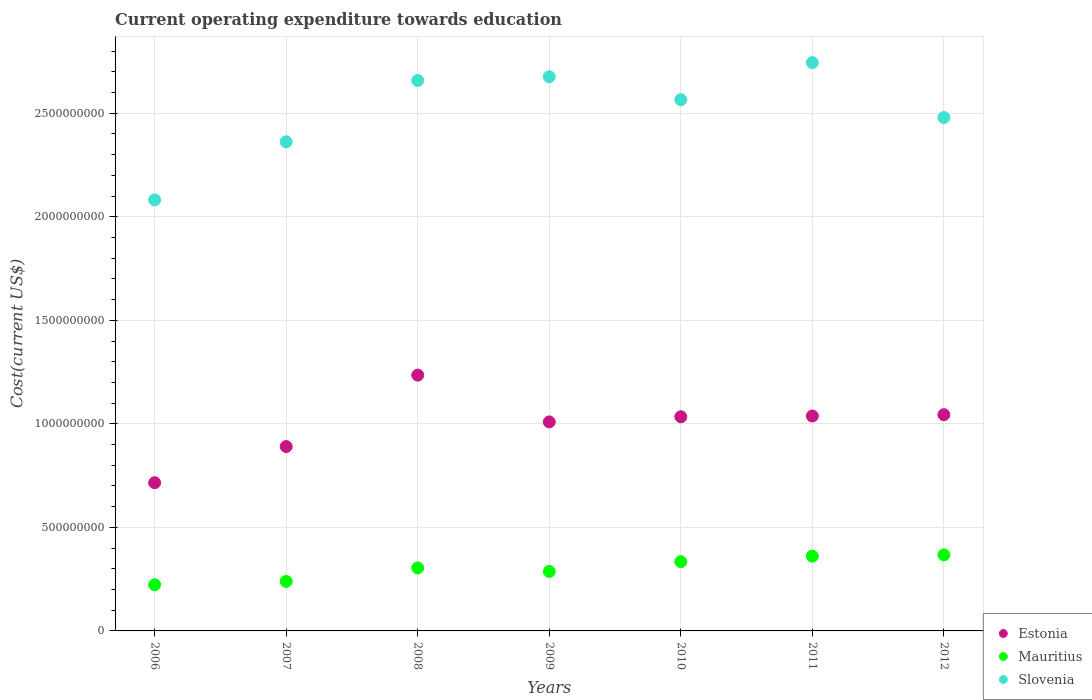What is the expenditure towards education in Estonia in 2006?
Offer a terse response. 7.16e+08. Across all years, what is the maximum expenditure towards education in Estonia?
Keep it short and to the point. 1.24e+09. Across all years, what is the minimum expenditure towards education in Mauritius?
Your answer should be very brief. 2.23e+08. In which year was the expenditure towards education in Estonia maximum?
Your answer should be very brief. 2008. What is the total expenditure towards education in Estonia in the graph?
Offer a very short reply. 6.97e+09. What is the difference between the expenditure towards education in Estonia in 2008 and that in 2010?
Offer a very short reply. 2.01e+08. What is the difference between the expenditure towards education in Estonia in 2012 and the expenditure towards education in Slovenia in 2007?
Give a very brief answer. -1.32e+09. What is the average expenditure towards education in Slovenia per year?
Provide a succinct answer. 2.51e+09. In the year 2008, what is the difference between the expenditure towards education in Slovenia and expenditure towards education in Mauritius?
Give a very brief answer. 2.35e+09. In how many years, is the expenditure towards education in Slovenia greater than 2600000000 US$?
Offer a very short reply. 3. What is the ratio of the expenditure towards education in Mauritius in 2006 to that in 2010?
Provide a short and direct response. 0.67. Is the expenditure towards education in Slovenia in 2006 less than that in 2008?
Offer a very short reply. Yes. What is the difference between the highest and the second highest expenditure towards education in Mauritius?
Offer a very short reply. 6.33e+06. What is the difference between the highest and the lowest expenditure towards education in Estonia?
Ensure brevity in your answer.  5.20e+08. Is the sum of the expenditure towards education in Slovenia in 2007 and 2012 greater than the maximum expenditure towards education in Mauritius across all years?
Your answer should be very brief. Yes. Is it the case that in every year, the sum of the expenditure towards education in Estonia and expenditure towards education in Slovenia  is greater than the expenditure towards education in Mauritius?
Provide a short and direct response. Yes. Does the expenditure towards education in Estonia monotonically increase over the years?
Provide a succinct answer. No. Is the expenditure towards education in Mauritius strictly less than the expenditure towards education in Slovenia over the years?
Offer a very short reply. Yes. How many dotlines are there?
Offer a very short reply. 3. How many years are there in the graph?
Your response must be concise. 7. Are the values on the major ticks of Y-axis written in scientific E-notation?
Offer a terse response. No. Does the graph contain any zero values?
Keep it short and to the point. No. Where does the legend appear in the graph?
Your answer should be compact. Bottom right. How many legend labels are there?
Your response must be concise. 3. What is the title of the graph?
Provide a succinct answer. Current operating expenditure towards education. Does "Guinea" appear as one of the legend labels in the graph?
Provide a succinct answer. No. What is the label or title of the Y-axis?
Ensure brevity in your answer.  Cost(current US$). What is the Cost(current US$) in Estonia in 2006?
Provide a short and direct response. 7.16e+08. What is the Cost(current US$) in Mauritius in 2006?
Your response must be concise. 2.23e+08. What is the Cost(current US$) of Slovenia in 2006?
Your response must be concise. 2.08e+09. What is the Cost(current US$) in Estonia in 2007?
Your response must be concise. 8.90e+08. What is the Cost(current US$) in Mauritius in 2007?
Provide a succinct answer. 2.39e+08. What is the Cost(current US$) in Slovenia in 2007?
Ensure brevity in your answer.  2.36e+09. What is the Cost(current US$) in Estonia in 2008?
Make the answer very short. 1.24e+09. What is the Cost(current US$) of Mauritius in 2008?
Give a very brief answer. 3.04e+08. What is the Cost(current US$) of Slovenia in 2008?
Your response must be concise. 2.66e+09. What is the Cost(current US$) in Estonia in 2009?
Provide a short and direct response. 1.01e+09. What is the Cost(current US$) of Mauritius in 2009?
Keep it short and to the point. 2.87e+08. What is the Cost(current US$) of Slovenia in 2009?
Give a very brief answer. 2.68e+09. What is the Cost(current US$) of Estonia in 2010?
Your answer should be very brief. 1.03e+09. What is the Cost(current US$) in Mauritius in 2010?
Offer a very short reply. 3.34e+08. What is the Cost(current US$) in Slovenia in 2010?
Your answer should be very brief. 2.57e+09. What is the Cost(current US$) in Estonia in 2011?
Keep it short and to the point. 1.04e+09. What is the Cost(current US$) in Mauritius in 2011?
Ensure brevity in your answer.  3.61e+08. What is the Cost(current US$) of Slovenia in 2011?
Offer a terse response. 2.74e+09. What is the Cost(current US$) in Estonia in 2012?
Your answer should be compact. 1.04e+09. What is the Cost(current US$) of Mauritius in 2012?
Offer a very short reply. 3.67e+08. What is the Cost(current US$) in Slovenia in 2012?
Make the answer very short. 2.48e+09. Across all years, what is the maximum Cost(current US$) in Estonia?
Keep it short and to the point. 1.24e+09. Across all years, what is the maximum Cost(current US$) in Mauritius?
Keep it short and to the point. 3.67e+08. Across all years, what is the maximum Cost(current US$) in Slovenia?
Ensure brevity in your answer.  2.74e+09. Across all years, what is the minimum Cost(current US$) in Estonia?
Ensure brevity in your answer.  7.16e+08. Across all years, what is the minimum Cost(current US$) of Mauritius?
Make the answer very short. 2.23e+08. Across all years, what is the minimum Cost(current US$) in Slovenia?
Make the answer very short. 2.08e+09. What is the total Cost(current US$) of Estonia in the graph?
Keep it short and to the point. 6.97e+09. What is the total Cost(current US$) of Mauritius in the graph?
Provide a short and direct response. 2.12e+09. What is the total Cost(current US$) in Slovenia in the graph?
Provide a succinct answer. 1.76e+1. What is the difference between the Cost(current US$) of Estonia in 2006 and that in 2007?
Provide a succinct answer. -1.75e+08. What is the difference between the Cost(current US$) of Mauritius in 2006 and that in 2007?
Keep it short and to the point. -1.62e+07. What is the difference between the Cost(current US$) of Slovenia in 2006 and that in 2007?
Make the answer very short. -2.80e+08. What is the difference between the Cost(current US$) in Estonia in 2006 and that in 2008?
Your answer should be compact. -5.20e+08. What is the difference between the Cost(current US$) of Mauritius in 2006 and that in 2008?
Give a very brief answer. -8.14e+07. What is the difference between the Cost(current US$) of Slovenia in 2006 and that in 2008?
Give a very brief answer. -5.76e+08. What is the difference between the Cost(current US$) of Estonia in 2006 and that in 2009?
Give a very brief answer. -2.94e+08. What is the difference between the Cost(current US$) of Mauritius in 2006 and that in 2009?
Make the answer very short. -6.43e+07. What is the difference between the Cost(current US$) in Slovenia in 2006 and that in 2009?
Offer a very short reply. -5.94e+08. What is the difference between the Cost(current US$) of Estonia in 2006 and that in 2010?
Ensure brevity in your answer.  -3.19e+08. What is the difference between the Cost(current US$) of Mauritius in 2006 and that in 2010?
Make the answer very short. -1.11e+08. What is the difference between the Cost(current US$) in Slovenia in 2006 and that in 2010?
Ensure brevity in your answer.  -4.84e+08. What is the difference between the Cost(current US$) in Estonia in 2006 and that in 2011?
Your answer should be very brief. -3.22e+08. What is the difference between the Cost(current US$) of Mauritius in 2006 and that in 2011?
Keep it short and to the point. -1.38e+08. What is the difference between the Cost(current US$) in Slovenia in 2006 and that in 2011?
Make the answer very short. -6.62e+08. What is the difference between the Cost(current US$) in Estonia in 2006 and that in 2012?
Make the answer very short. -3.29e+08. What is the difference between the Cost(current US$) of Mauritius in 2006 and that in 2012?
Provide a succinct answer. -1.44e+08. What is the difference between the Cost(current US$) in Slovenia in 2006 and that in 2012?
Provide a succinct answer. -3.98e+08. What is the difference between the Cost(current US$) in Estonia in 2007 and that in 2008?
Offer a terse response. -3.45e+08. What is the difference between the Cost(current US$) in Mauritius in 2007 and that in 2008?
Your response must be concise. -6.53e+07. What is the difference between the Cost(current US$) of Slovenia in 2007 and that in 2008?
Keep it short and to the point. -2.96e+08. What is the difference between the Cost(current US$) in Estonia in 2007 and that in 2009?
Make the answer very short. -1.19e+08. What is the difference between the Cost(current US$) in Mauritius in 2007 and that in 2009?
Your answer should be very brief. -4.81e+07. What is the difference between the Cost(current US$) in Slovenia in 2007 and that in 2009?
Give a very brief answer. -3.14e+08. What is the difference between the Cost(current US$) in Estonia in 2007 and that in 2010?
Your response must be concise. -1.44e+08. What is the difference between the Cost(current US$) in Mauritius in 2007 and that in 2010?
Your response must be concise. -9.53e+07. What is the difference between the Cost(current US$) of Slovenia in 2007 and that in 2010?
Your response must be concise. -2.03e+08. What is the difference between the Cost(current US$) in Estonia in 2007 and that in 2011?
Your answer should be very brief. -1.48e+08. What is the difference between the Cost(current US$) in Mauritius in 2007 and that in 2011?
Provide a short and direct response. -1.22e+08. What is the difference between the Cost(current US$) of Slovenia in 2007 and that in 2011?
Provide a succinct answer. -3.82e+08. What is the difference between the Cost(current US$) of Estonia in 2007 and that in 2012?
Ensure brevity in your answer.  -1.54e+08. What is the difference between the Cost(current US$) of Mauritius in 2007 and that in 2012?
Your response must be concise. -1.28e+08. What is the difference between the Cost(current US$) in Slovenia in 2007 and that in 2012?
Give a very brief answer. -1.17e+08. What is the difference between the Cost(current US$) in Estonia in 2008 and that in 2009?
Offer a very short reply. 2.26e+08. What is the difference between the Cost(current US$) of Mauritius in 2008 and that in 2009?
Make the answer very short. 1.71e+07. What is the difference between the Cost(current US$) of Slovenia in 2008 and that in 2009?
Give a very brief answer. -1.81e+07. What is the difference between the Cost(current US$) of Estonia in 2008 and that in 2010?
Make the answer very short. 2.01e+08. What is the difference between the Cost(current US$) of Mauritius in 2008 and that in 2010?
Your response must be concise. -3.00e+07. What is the difference between the Cost(current US$) in Slovenia in 2008 and that in 2010?
Keep it short and to the point. 9.27e+07. What is the difference between the Cost(current US$) in Estonia in 2008 and that in 2011?
Your response must be concise. 1.97e+08. What is the difference between the Cost(current US$) in Mauritius in 2008 and that in 2011?
Your response must be concise. -5.66e+07. What is the difference between the Cost(current US$) in Slovenia in 2008 and that in 2011?
Your answer should be very brief. -8.61e+07. What is the difference between the Cost(current US$) in Estonia in 2008 and that in 2012?
Give a very brief answer. 1.91e+08. What is the difference between the Cost(current US$) in Mauritius in 2008 and that in 2012?
Offer a very short reply. -6.30e+07. What is the difference between the Cost(current US$) of Slovenia in 2008 and that in 2012?
Give a very brief answer. 1.79e+08. What is the difference between the Cost(current US$) of Estonia in 2009 and that in 2010?
Offer a very short reply. -2.50e+07. What is the difference between the Cost(current US$) of Mauritius in 2009 and that in 2010?
Your answer should be compact. -4.72e+07. What is the difference between the Cost(current US$) of Slovenia in 2009 and that in 2010?
Make the answer very short. 1.11e+08. What is the difference between the Cost(current US$) in Estonia in 2009 and that in 2011?
Your answer should be very brief. -2.87e+07. What is the difference between the Cost(current US$) in Mauritius in 2009 and that in 2011?
Give a very brief answer. -7.38e+07. What is the difference between the Cost(current US$) in Slovenia in 2009 and that in 2011?
Offer a terse response. -6.79e+07. What is the difference between the Cost(current US$) of Estonia in 2009 and that in 2012?
Your response must be concise. -3.50e+07. What is the difference between the Cost(current US$) in Mauritius in 2009 and that in 2012?
Your response must be concise. -8.01e+07. What is the difference between the Cost(current US$) in Slovenia in 2009 and that in 2012?
Offer a terse response. 1.97e+08. What is the difference between the Cost(current US$) in Estonia in 2010 and that in 2011?
Your answer should be very brief. -3.72e+06. What is the difference between the Cost(current US$) of Mauritius in 2010 and that in 2011?
Keep it short and to the point. -2.66e+07. What is the difference between the Cost(current US$) in Slovenia in 2010 and that in 2011?
Make the answer very short. -1.79e+08. What is the difference between the Cost(current US$) of Estonia in 2010 and that in 2012?
Provide a succinct answer. -1.00e+07. What is the difference between the Cost(current US$) of Mauritius in 2010 and that in 2012?
Your answer should be very brief. -3.29e+07. What is the difference between the Cost(current US$) in Slovenia in 2010 and that in 2012?
Provide a succinct answer. 8.59e+07. What is the difference between the Cost(current US$) of Estonia in 2011 and that in 2012?
Your response must be concise. -6.29e+06. What is the difference between the Cost(current US$) of Mauritius in 2011 and that in 2012?
Your response must be concise. -6.33e+06. What is the difference between the Cost(current US$) in Slovenia in 2011 and that in 2012?
Your answer should be very brief. 2.65e+08. What is the difference between the Cost(current US$) of Estonia in 2006 and the Cost(current US$) of Mauritius in 2007?
Give a very brief answer. 4.77e+08. What is the difference between the Cost(current US$) in Estonia in 2006 and the Cost(current US$) in Slovenia in 2007?
Your response must be concise. -1.65e+09. What is the difference between the Cost(current US$) of Mauritius in 2006 and the Cost(current US$) of Slovenia in 2007?
Ensure brevity in your answer.  -2.14e+09. What is the difference between the Cost(current US$) of Estonia in 2006 and the Cost(current US$) of Mauritius in 2008?
Make the answer very short. 4.11e+08. What is the difference between the Cost(current US$) of Estonia in 2006 and the Cost(current US$) of Slovenia in 2008?
Ensure brevity in your answer.  -1.94e+09. What is the difference between the Cost(current US$) in Mauritius in 2006 and the Cost(current US$) in Slovenia in 2008?
Keep it short and to the point. -2.44e+09. What is the difference between the Cost(current US$) in Estonia in 2006 and the Cost(current US$) in Mauritius in 2009?
Provide a succinct answer. 4.28e+08. What is the difference between the Cost(current US$) of Estonia in 2006 and the Cost(current US$) of Slovenia in 2009?
Provide a succinct answer. -1.96e+09. What is the difference between the Cost(current US$) in Mauritius in 2006 and the Cost(current US$) in Slovenia in 2009?
Keep it short and to the point. -2.45e+09. What is the difference between the Cost(current US$) of Estonia in 2006 and the Cost(current US$) of Mauritius in 2010?
Keep it short and to the point. 3.81e+08. What is the difference between the Cost(current US$) of Estonia in 2006 and the Cost(current US$) of Slovenia in 2010?
Offer a very short reply. -1.85e+09. What is the difference between the Cost(current US$) of Mauritius in 2006 and the Cost(current US$) of Slovenia in 2010?
Offer a terse response. -2.34e+09. What is the difference between the Cost(current US$) in Estonia in 2006 and the Cost(current US$) in Mauritius in 2011?
Keep it short and to the point. 3.55e+08. What is the difference between the Cost(current US$) in Estonia in 2006 and the Cost(current US$) in Slovenia in 2011?
Keep it short and to the point. -2.03e+09. What is the difference between the Cost(current US$) of Mauritius in 2006 and the Cost(current US$) of Slovenia in 2011?
Your response must be concise. -2.52e+09. What is the difference between the Cost(current US$) of Estonia in 2006 and the Cost(current US$) of Mauritius in 2012?
Your response must be concise. 3.48e+08. What is the difference between the Cost(current US$) in Estonia in 2006 and the Cost(current US$) in Slovenia in 2012?
Provide a short and direct response. -1.76e+09. What is the difference between the Cost(current US$) in Mauritius in 2006 and the Cost(current US$) in Slovenia in 2012?
Make the answer very short. -2.26e+09. What is the difference between the Cost(current US$) in Estonia in 2007 and the Cost(current US$) in Mauritius in 2008?
Offer a very short reply. 5.86e+08. What is the difference between the Cost(current US$) in Estonia in 2007 and the Cost(current US$) in Slovenia in 2008?
Your response must be concise. -1.77e+09. What is the difference between the Cost(current US$) in Mauritius in 2007 and the Cost(current US$) in Slovenia in 2008?
Keep it short and to the point. -2.42e+09. What is the difference between the Cost(current US$) in Estonia in 2007 and the Cost(current US$) in Mauritius in 2009?
Ensure brevity in your answer.  6.03e+08. What is the difference between the Cost(current US$) of Estonia in 2007 and the Cost(current US$) of Slovenia in 2009?
Your answer should be compact. -1.79e+09. What is the difference between the Cost(current US$) in Mauritius in 2007 and the Cost(current US$) in Slovenia in 2009?
Your answer should be very brief. -2.44e+09. What is the difference between the Cost(current US$) in Estonia in 2007 and the Cost(current US$) in Mauritius in 2010?
Offer a very short reply. 5.56e+08. What is the difference between the Cost(current US$) in Estonia in 2007 and the Cost(current US$) in Slovenia in 2010?
Your response must be concise. -1.67e+09. What is the difference between the Cost(current US$) in Mauritius in 2007 and the Cost(current US$) in Slovenia in 2010?
Make the answer very short. -2.33e+09. What is the difference between the Cost(current US$) in Estonia in 2007 and the Cost(current US$) in Mauritius in 2011?
Make the answer very short. 5.29e+08. What is the difference between the Cost(current US$) of Estonia in 2007 and the Cost(current US$) of Slovenia in 2011?
Keep it short and to the point. -1.85e+09. What is the difference between the Cost(current US$) of Mauritius in 2007 and the Cost(current US$) of Slovenia in 2011?
Provide a succinct answer. -2.51e+09. What is the difference between the Cost(current US$) in Estonia in 2007 and the Cost(current US$) in Mauritius in 2012?
Your answer should be very brief. 5.23e+08. What is the difference between the Cost(current US$) of Estonia in 2007 and the Cost(current US$) of Slovenia in 2012?
Offer a terse response. -1.59e+09. What is the difference between the Cost(current US$) of Mauritius in 2007 and the Cost(current US$) of Slovenia in 2012?
Give a very brief answer. -2.24e+09. What is the difference between the Cost(current US$) in Estonia in 2008 and the Cost(current US$) in Mauritius in 2009?
Provide a succinct answer. 9.48e+08. What is the difference between the Cost(current US$) in Estonia in 2008 and the Cost(current US$) in Slovenia in 2009?
Offer a very short reply. -1.44e+09. What is the difference between the Cost(current US$) of Mauritius in 2008 and the Cost(current US$) of Slovenia in 2009?
Make the answer very short. -2.37e+09. What is the difference between the Cost(current US$) of Estonia in 2008 and the Cost(current US$) of Mauritius in 2010?
Ensure brevity in your answer.  9.01e+08. What is the difference between the Cost(current US$) in Estonia in 2008 and the Cost(current US$) in Slovenia in 2010?
Ensure brevity in your answer.  -1.33e+09. What is the difference between the Cost(current US$) in Mauritius in 2008 and the Cost(current US$) in Slovenia in 2010?
Offer a terse response. -2.26e+09. What is the difference between the Cost(current US$) of Estonia in 2008 and the Cost(current US$) of Mauritius in 2011?
Give a very brief answer. 8.74e+08. What is the difference between the Cost(current US$) in Estonia in 2008 and the Cost(current US$) in Slovenia in 2011?
Keep it short and to the point. -1.51e+09. What is the difference between the Cost(current US$) in Mauritius in 2008 and the Cost(current US$) in Slovenia in 2011?
Your response must be concise. -2.44e+09. What is the difference between the Cost(current US$) of Estonia in 2008 and the Cost(current US$) of Mauritius in 2012?
Offer a very short reply. 8.68e+08. What is the difference between the Cost(current US$) in Estonia in 2008 and the Cost(current US$) in Slovenia in 2012?
Offer a terse response. -1.24e+09. What is the difference between the Cost(current US$) of Mauritius in 2008 and the Cost(current US$) of Slovenia in 2012?
Keep it short and to the point. -2.18e+09. What is the difference between the Cost(current US$) of Estonia in 2009 and the Cost(current US$) of Mauritius in 2010?
Provide a short and direct response. 6.75e+08. What is the difference between the Cost(current US$) in Estonia in 2009 and the Cost(current US$) in Slovenia in 2010?
Provide a short and direct response. -1.56e+09. What is the difference between the Cost(current US$) in Mauritius in 2009 and the Cost(current US$) in Slovenia in 2010?
Provide a short and direct response. -2.28e+09. What is the difference between the Cost(current US$) in Estonia in 2009 and the Cost(current US$) in Mauritius in 2011?
Provide a short and direct response. 6.48e+08. What is the difference between the Cost(current US$) in Estonia in 2009 and the Cost(current US$) in Slovenia in 2011?
Ensure brevity in your answer.  -1.73e+09. What is the difference between the Cost(current US$) in Mauritius in 2009 and the Cost(current US$) in Slovenia in 2011?
Make the answer very short. -2.46e+09. What is the difference between the Cost(current US$) in Estonia in 2009 and the Cost(current US$) in Mauritius in 2012?
Your answer should be very brief. 6.42e+08. What is the difference between the Cost(current US$) in Estonia in 2009 and the Cost(current US$) in Slovenia in 2012?
Offer a very short reply. -1.47e+09. What is the difference between the Cost(current US$) of Mauritius in 2009 and the Cost(current US$) of Slovenia in 2012?
Offer a terse response. -2.19e+09. What is the difference between the Cost(current US$) in Estonia in 2010 and the Cost(current US$) in Mauritius in 2011?
Give a very brief answer. 6.73e+08. What is the difference between the Cost(current US$) of Estonia in 2010 and the Cost(current US$) of Slovenia in 2011?
Your answer should be compact. -1.71e+09. What is the difference between the Cost(current US$) of Mauritius in 2010 and the Cost(current US$) of Slovenia in 2011?
Your answer should be compact. -2.41e+09. What is the difference between the Cost(current US$) in Estonia in 2010 and the Cost(current US$) in Mauritius in 2012?
Provide a short and direct response. 6.67e+08. What is the difference between the Cost(current US$) of Estonia in 2010 and the Cost(current US$) of Slovenia in 2012?
Keep it short and to the point. -1.45e+09. What is the difference between the Cost(current US$) of Mauritius in 2010 and the Cost(current US$) of Slovenia in 2012?
Offer a very short reply. -2.15e+09. What is the difference between the Cost(current US$) of Estonia in 2011 and the Cost(current US$) of Mauritius in 2012?
Ensure brevity in your answer.  6.71e+08. What is the difference between the Cost(current US$) in Estonia in 2011 and the Cost(current US$) in Slovenia in 2012?
Provide a short and direct response. -1.44e+09. What is the difference between the Cost(current US$) in Mauritius in 2011 and the Cost(current US$) in Slovenia in 2012?
Provide a short and direct response. -2.12e+09. What is the average Cost(current US$) in Estonia per year?
Provide a short and direct response. 9.95e+08. What is the average Cost(current US$) in Mauritius per year?
Make the answer very short. 3.02e+08. What is the average Cost(current US$) of Slovenia per year?
Give a very brief answer. 2.51e+09. In the year 2006, what is the difference between the Cost(current US$) of Estonia and Cost(current US$) of Mauritius?
Keep it short and to the point. 4.93e+08. In the year 2006, what is the difference between the Cost(current US$) of Estonia and Cost(current US$) of Slovenia?
Make the answer very short. -1.37e+09. In the year 2006, what is the difference between the Cost(current US$) in Mauritius and Cost(current US$) in Slovenia?
Your response must be concise. -1.86e+09. In the year 2007, what is the difference between the Cost(current US$) of Estonia and Cost(current US$) of Mauritius?
Your response must be concise. 6.51e+08. In the year 2007, what is the difference between the Cost(current US$) of Estonia and Cost(current US$) of Slovenia?
Your answer should be compact. -1.47e+09. In the year 2007, what is the difference between the Cost(current US$) in Mauritius and Cost(current US$) in Slovenia?
Your answer should be very brief. -2.12e+09. In the year 2008, what is the difference between the Cost(current US$) in Estonia and Cost(current US$) in Mauritius?
Your answer should be very brief. 9.31e+08. In the year 2008, what is the difference between the Cost(current US$) of Estonia and Cost(current US$) of Slovenia?
Provide a short and direct response. -1.42e+09. In the year 2008, what is the difference between the Cost(current US$) of Mauritius and Cost(current US$) of Slovenia?
Your answer should be very brief. -2.35e+09. In the year 2009, what is the difference between the Cost(current US$) in Estonia and Cost(current US$) in Mauritius?
Keep it short and to the point. 7.22e+08. In the year 2009, what is the difference between the Cost(current US$) of Estonia and Cost(current US$) of Slovenia?
Make the answer very short. -1.67e+09. In the year 2009, what is the difference between the Cost(current US$) of Mauritius and Cost(current US$) of Slovenia?
Offer a very short reply. -2.39e+09. In the year 2010, what is the difference between the Cost(current US$) of Estonia and Cost(current US$) of Mauritius?
Your answer should be compact. 7.00e+08. In the year 2010, what is the difference between the Cost(current US$) in Estonia and Cost(current US$) in Slovenia?
Offer a very short reply. -1.53e+09. In the year 2010, what is the difference between the Cost(current US$) in Mauritius and Cost(current US$) in Slovenia?
Your response must be concise. -2.23e+09. In the year 2011, what is the difference between the Cost(current US$) of Estonia and Cost(current US$) of Mauritius?
Your response must be concise. 6.77e+08. In the year 2011, what is the difference between the Cost(current US$) in Estonia and Cost(current US$) in Slovenia?
Make the answer very short. -1.71e+09. In the year 2011, what is the difference between the Cost(current US$) in Mauritius and Cost(current US$) in Slovenia?
Make the answer very short. -2.38e+09. In the year 2012, what is the difference between the Cost(current US$) of Estonia and Cost(current US$) of Mauritius?
Offer a very short reply. 6.77e+08. In the year 2012, what is the difference between the Cost(current US$) of Estonia and Cost(current US$) of Slovenia?
Your answer should be compact. -1.44e+09. In the year 2012, what is the difference between the Cost(current US$) of Mauritius and Cost(current US$) of Slovenia?
Keep it short and to the point. -2.11e+09. What is the ratio of the Cost(current US$) of Estonia in 2006 to that in 2007?
Offer a very short reply. 0.8. What is the ratio of the Cost(current US$) of Mauritius in 2006 to that in 2007?
Make the answer very short. 0.93. What is the ratio of the Cost(current US$) of Slovenia in 2006 to that in 2007?
Provide a succinct answer. 0.88. What is the ratio of the Cost(current US$) in Estonia in 2006 to that in 2008?
Offer a very short reply. 0.58. What is the ratio of the Cost(current US$) in Mauritius in 2006 to that in 2008?
Offer a terse response. 0.73. What is the ratio of the Cost(current US$) in Slovenia in 2006 to that in 2008?
Provide a short and direct response. 0.78. What is the ratio of the Cost(current US$) of Estonia in 2006 to that in 2009?
Keep it short and to the point. 0.71. What is the ratio of the Cost(current US$) of Mauritius in 2006 to that in 2009?
Provide a short and direct response. 0.78. What is the ratio of the Cost(current US$) of Slovenia in 2006 to that in 2009?
Provide a short and direct response. 0.78. What is the ratio of the Cost(current US$) of Estonia in 2006 to that in 2010?
Your response must be concise. 0.69. What is the ratio of the Cost(current US$) in Mauritius in 2006 to that in 2010?
Make the answer very short. 0.67. What is the ratio of the Cost(current US$) in Slovenia in 2006 to that in 2010?
Keep it short and to the point. 0.81. What is the ratio of the Cost(current US$) of Estonia in 2006 to that in 2011?
Give a very brief answer. 0.69. What is the ratio of the Cost(current US$) of Mauritius in 2006 to that in 2011?
Your answer should be compact. 0.62. What is the ratio of the Cost(current US$) in Slovenia in 2006 to that in 2011?
Provide a succinct answer. 0.76. What is the ratio of the Cost(current US$) of Estonia in 2006 to that in 2012?
Keep it short and to the point. 0.69. What is the ratio of the Cost(current US$) in Mauritius in 2006 to that in 2012?
Your response must be concise. 0.61. What is the ratio of the Cost(current US$) of Slovenia in 2006 to that in 2012?
Keep it short and to the point. 0.84. What is the ratio of the Cost(current US$) of Estonia in 2007 to that in 2008?
Your answer should be compact. 0.72. What is the ratio of the Cost(current US$) of Mauritius in 2007 to that in 2008?
Your answer should be compact. 0.79. What is the ratio of the Cost(current US$) in Slovenia in 2007 to that in 2008?
Provide a short and direct response. 0.89. What is the ratio of the Cost(current US$) in Estonia in 2007 to that in 2009?
Provide a short and direct response. 0.88. What is the ratio of the Cost(current US$) of Mauritius in 2007 to that in 2009?
Ensure brevity in your answer.  0.83. What is the ratio of the Cost(current US$) in Slovenia in 2007 to that in 2009?
Ensure brevity in your answer.  0.88. What is the ratio of the Cost(current US$) in Estonia in 2007 to that in 2010?
Offer a terse response. 0.86. What is the ratio of the Cost(current US$) of Mauritius in 2007 to that in 2010?
Give a very brief answer. 0.71. What is the ratio of the Cost(current US$) in Slovenia in 2007 to that in 2010?
Your answer should be very brief. 0.92. What is the ratio of the Cost(current US$) of Estonia in 2007 to that in 2011?
Your answer should be very brief. 0.86. What is the ratio of the Cost(current US$) in Mauritius in 2007 to that in 2011?
Provide a succinct answer. 0.66. What is the ratio of the Cost(current US$) of Slovenia in 2007 to that in 2011?
Keep it short and to the point. 0.86. What is the ratio of the Cost(current US$) in Estonia in 2007 to that in 2012?
Offer a terse response. 0.85. What is the ratio of the Cost(current US$) in Mauritius in 2007 to that in 2012?
Ensure brevity in your answer.  0.65. What is the ratio of the Cost(current US$) in Slovenia in 2007 to that in 2012?
Your answer should be very brief. 0.95. What is the ratio of the Cost(current US$) of Estonia in 2008 to that in 2009?
Offer a very short reply. 1.22. What is the ratio of the Cost(current US$) of Mauritius in 2008 to that in 2009?
Provide a succinct answer. 1.06. What is the ratio of the Cost(current US$) of Slovenia in 2008 to that in 2009?
Your answer should be very brief. 0.99. What is the ratio of the Cost(current US$) of Estonia in 2008 to that in 2010?
Make the answer very short. 1.19. What is the ratio of the Cost(current US$) in Mauritius in 2008 to that in 2010?
Your answer should be compact. 0.91. What is the ratio of the Cost(current US$) of Slovenia in 2008 to that in 2010?
Provide a short and direct response. 1.04. What is the ratio of the Cost(current US$) in Estonia in 2008 to that in 2011?
Your response must be concise. 1.19. What is the ratio of the Cost(current US$) in Mauritius in 2008 to that in 2011?
Offer a terse response. 0.84. What is the ratio of the Cost(current US$) of Slovenia in 2008 to that in 2011?
Offer a terse response. 0.97. What is the ratio of the Cost(current US$) in Estonia in 2008 to that in 2012?
Give a very brief answer. 1.18. What is the ratio of the Cost(current US$) of Mauritius in 2008 to that in 2012?
Your answer should be compact. 0.83. What is the ratio of the Cost(current US$) in Slovenia in 2008 to that in 2012?
Make the answer very short. 1.07. What is the ratio of the Cost(current US$) in Estonia in 2009 to that in 2010?
Offer a terse response. 0.98. What is the ratio of the Cost(current US$) of Mauritius in 2009 to that in 2010?
Your answer should be very brief. 0.86. What is the ratio of the Cost(current US$) in Slovenia in 2009 to that in 2010?
Make the answer very short. 1.04. What is the ratio of the Cost(current US$) of Estonia in 2009 to that in 2011?
Ensure brevity in your answer.  0.97. What is the ratio of the Cost(current US$) in Mauritius in 2009 to that in 2011?
Provide a short and direct response. 0.8. What is the ratio of the Cost(current US$) of Slovenia in 2009 to that in 2011?
Provide a succinct answer. 0.98. What is the ratio of the Cost(current US$) in Estonia in 2009 to that in 2012?
Provide a short and direct response. 0.97. What is the ratio of the Cost(current US$) of Mauritius in 2009 to that in 2012?
Provide a short and direct response. 0.78. What is the ratio of the Cost(current US$) in Slovenia in 2009 to that in 2012?
Offer a terse response. 1.08. What is the ratio of the Cost(current US$) of Estonia in 2010 to that in 2011?
Provide a short and direct response. 1. What is the ratio of the Cost(current US$) in Mauritius in 2010 to that in 2011?
Make the answer very short. 0.93. What is the ratio of the Cost(current US$) in Slovenia in 2010 to that in 2011?
Your answer should be compact. 0.93. What is the ratio of the Cost(current US$) in Mauritius in 2010 to that in 2012?
Ensure brevity in your answer.  0.91. What is the ratio of the Cost(current US$) in Slovenia in 2010 to that in 2012?
Give a very brief answer. 1.03. What is the ratio of the Cost(current US$) of Estonia in 2011 to that in 2012?
Give a very brief answer. 0.99. What is the ratio of the Cost(current US$) of Mauritius in 2011 to that in 2012?
Give a very brief answer. 0.98. What is the ratio of the Cost(current US$) in Slovenia in 2011 to that in 2012?
Make the answer very short. 1.11. What is the difference between the highest and the second highest Cost(current US$) of Estonia?
Your answer should be very brief. 1.91e+08. What is the difference between the highest and the second highest Cost(current US$) of Mauritius?
Provide a succinct answer. 6.33e+06. What is the difference between the highest and the second highest Cost(current US$) of Slovenia?
Your response must be concise. 6.79e+07. What is the difference between the highest and the lowest Cost(current US$) in Estonia?
Your answer should be very brief. 5.20e+08. What is the difference between the highest and the lowest Cost(current US$) of Mauritius?
Provide a short and direct response. 1.44e+08. What is the difference between the highest and the lowest Cost(current US$) in Slovenia?
Your response must be concise. 6.62e+08. 